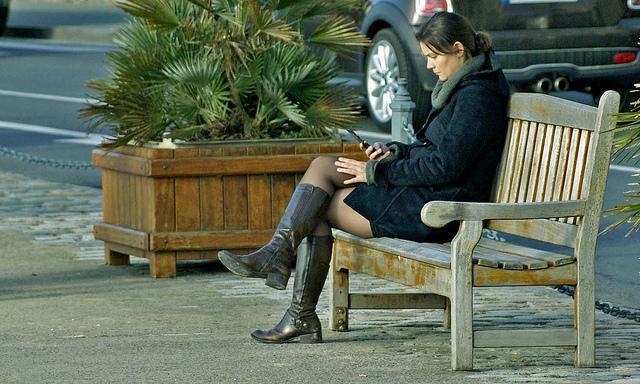What is she doing?
Pick the right solution, then justify: 'Answer: answer
Rationale: rationale.'
Options: Talkin, checking facebook, ordering lunch, texting friend. Answer: texting friend.
Rationale: She has a phone in her hand and this is before higher end phones.  she isn't talking on it. 